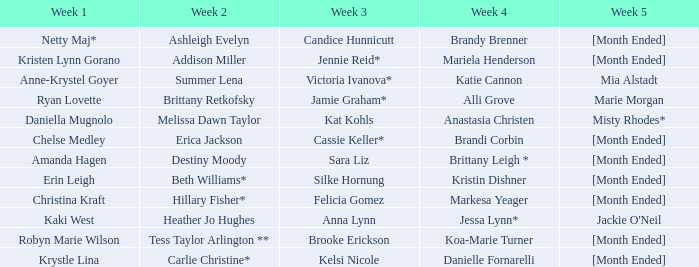What is the week 1 with candice hunnicutt in week 3? Netty Maj*. 